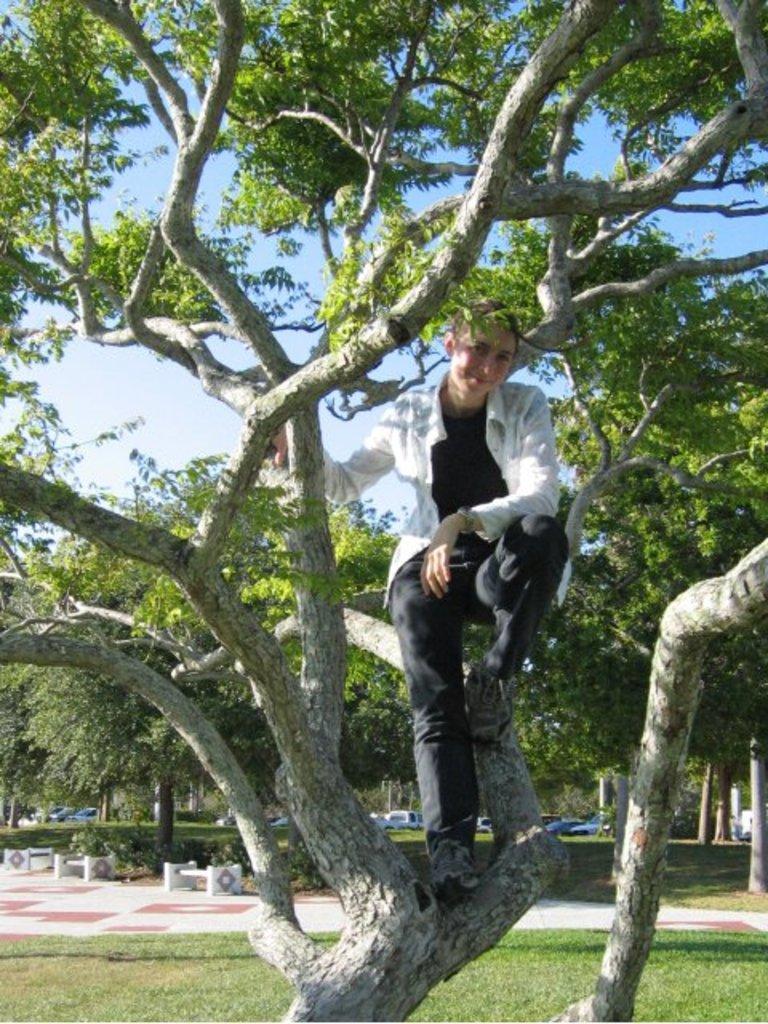Please provide a concise description of this image. In this image I can see a person wearing white and black colored dress is on a tree which is green and ash in color. In the background I can see few benches, few trees, few vehicles and the sky. 